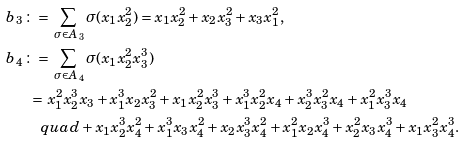Convert formula to latex. <formula><loc_0><loc_0><loc_500><loc_500>b _ { 3 } \, & \colon = \, \sum _ { \sigma \in A _ { 3 } } \sigma ( x _ { 1 } x _ { 2 } ^ { 2 } ) = x _ { 1 } x _ { 2 } ^ { 2 } + x _ { 2 } x _ { 3 } ^ { 2 } + x _ { 3 } x _ { 1 } ^ { 2 } , \\ b _ { 4 } \, & \colon = \, \sum _ { \sigma \in A _ { 4 } } \sigma ( x _ { 1 } x _ { 2 } ^ { 2 } x _ { 3 } ^ { 3 } ) \\ & \ = \, x _ { 1 } ^ { 2 } x _ { 2 } ^ { 3 } x _ { 3 } + x _ { 1 } ^ { 3 } x _ { 2 } x _ { 3 } ^ { 2 } + x _ { 1 } x _ { 2 } ^ { 2 } x _ { 3 } ^ { 3 } + x _ { 1 } ^ { 3 } x _ { 2 } ^ { 2 } x _ { 4 } + x _ { 2 } ^ { 3 } x _ { 3 } ^ { 2 } x _ { 4 } + x _ { 1 } ^ { 2 } x _ { 3 } ^ { 3 } x _ { 4 } \\ & \quad q u a d + x _ { 1 } x _ { 2 } ^ { 3 } x _ { 4 } ^ { 2 } + x _ { 1 } ^ { 3 } x _ { 3 } x _ { 4 } ^ { 2 } + x _ { 2 } x _ { 3 } ^ { 3 } x _ { 4 } ^ { 2 } + x _ { 1 } ^ { 2 } x _ { 2 } x _ { 4 } ^ { 3 } + x _ { 2 } ^ { 2 } x _ { 3 } x _ { 4 } ^ { 3 } + x _ { 1 } x _ { 3 } ^ { 2 } x _ { 4 } ^ { 3 } .</formula> 